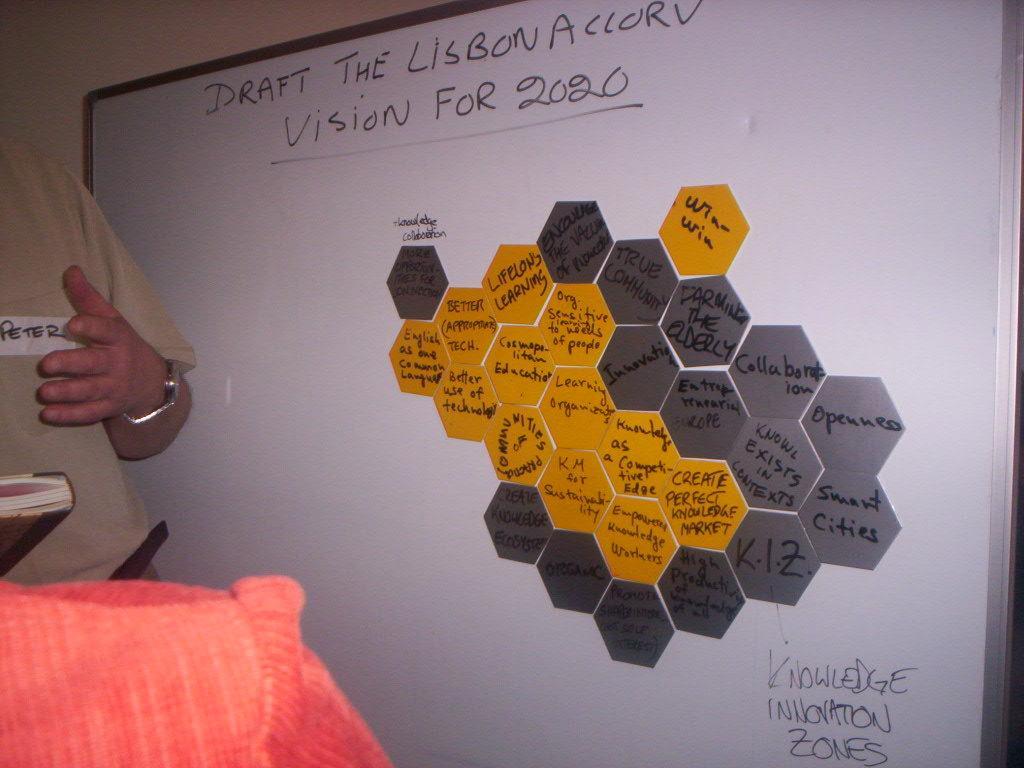Could you give a brief overview of what you see in this image? In this image, we can see a white board. On the board we can see some text and few color objects. On the left side of the image, we can see a person, book and cloth. Left side top corner, there is a wall. 